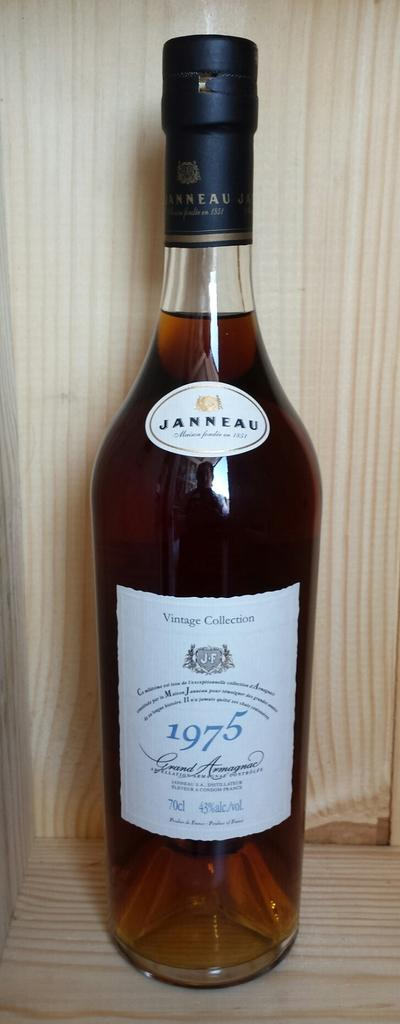Provide a one-sentence caption for the provided image. A bottle of Janneau liquor is 43% alcohol. 